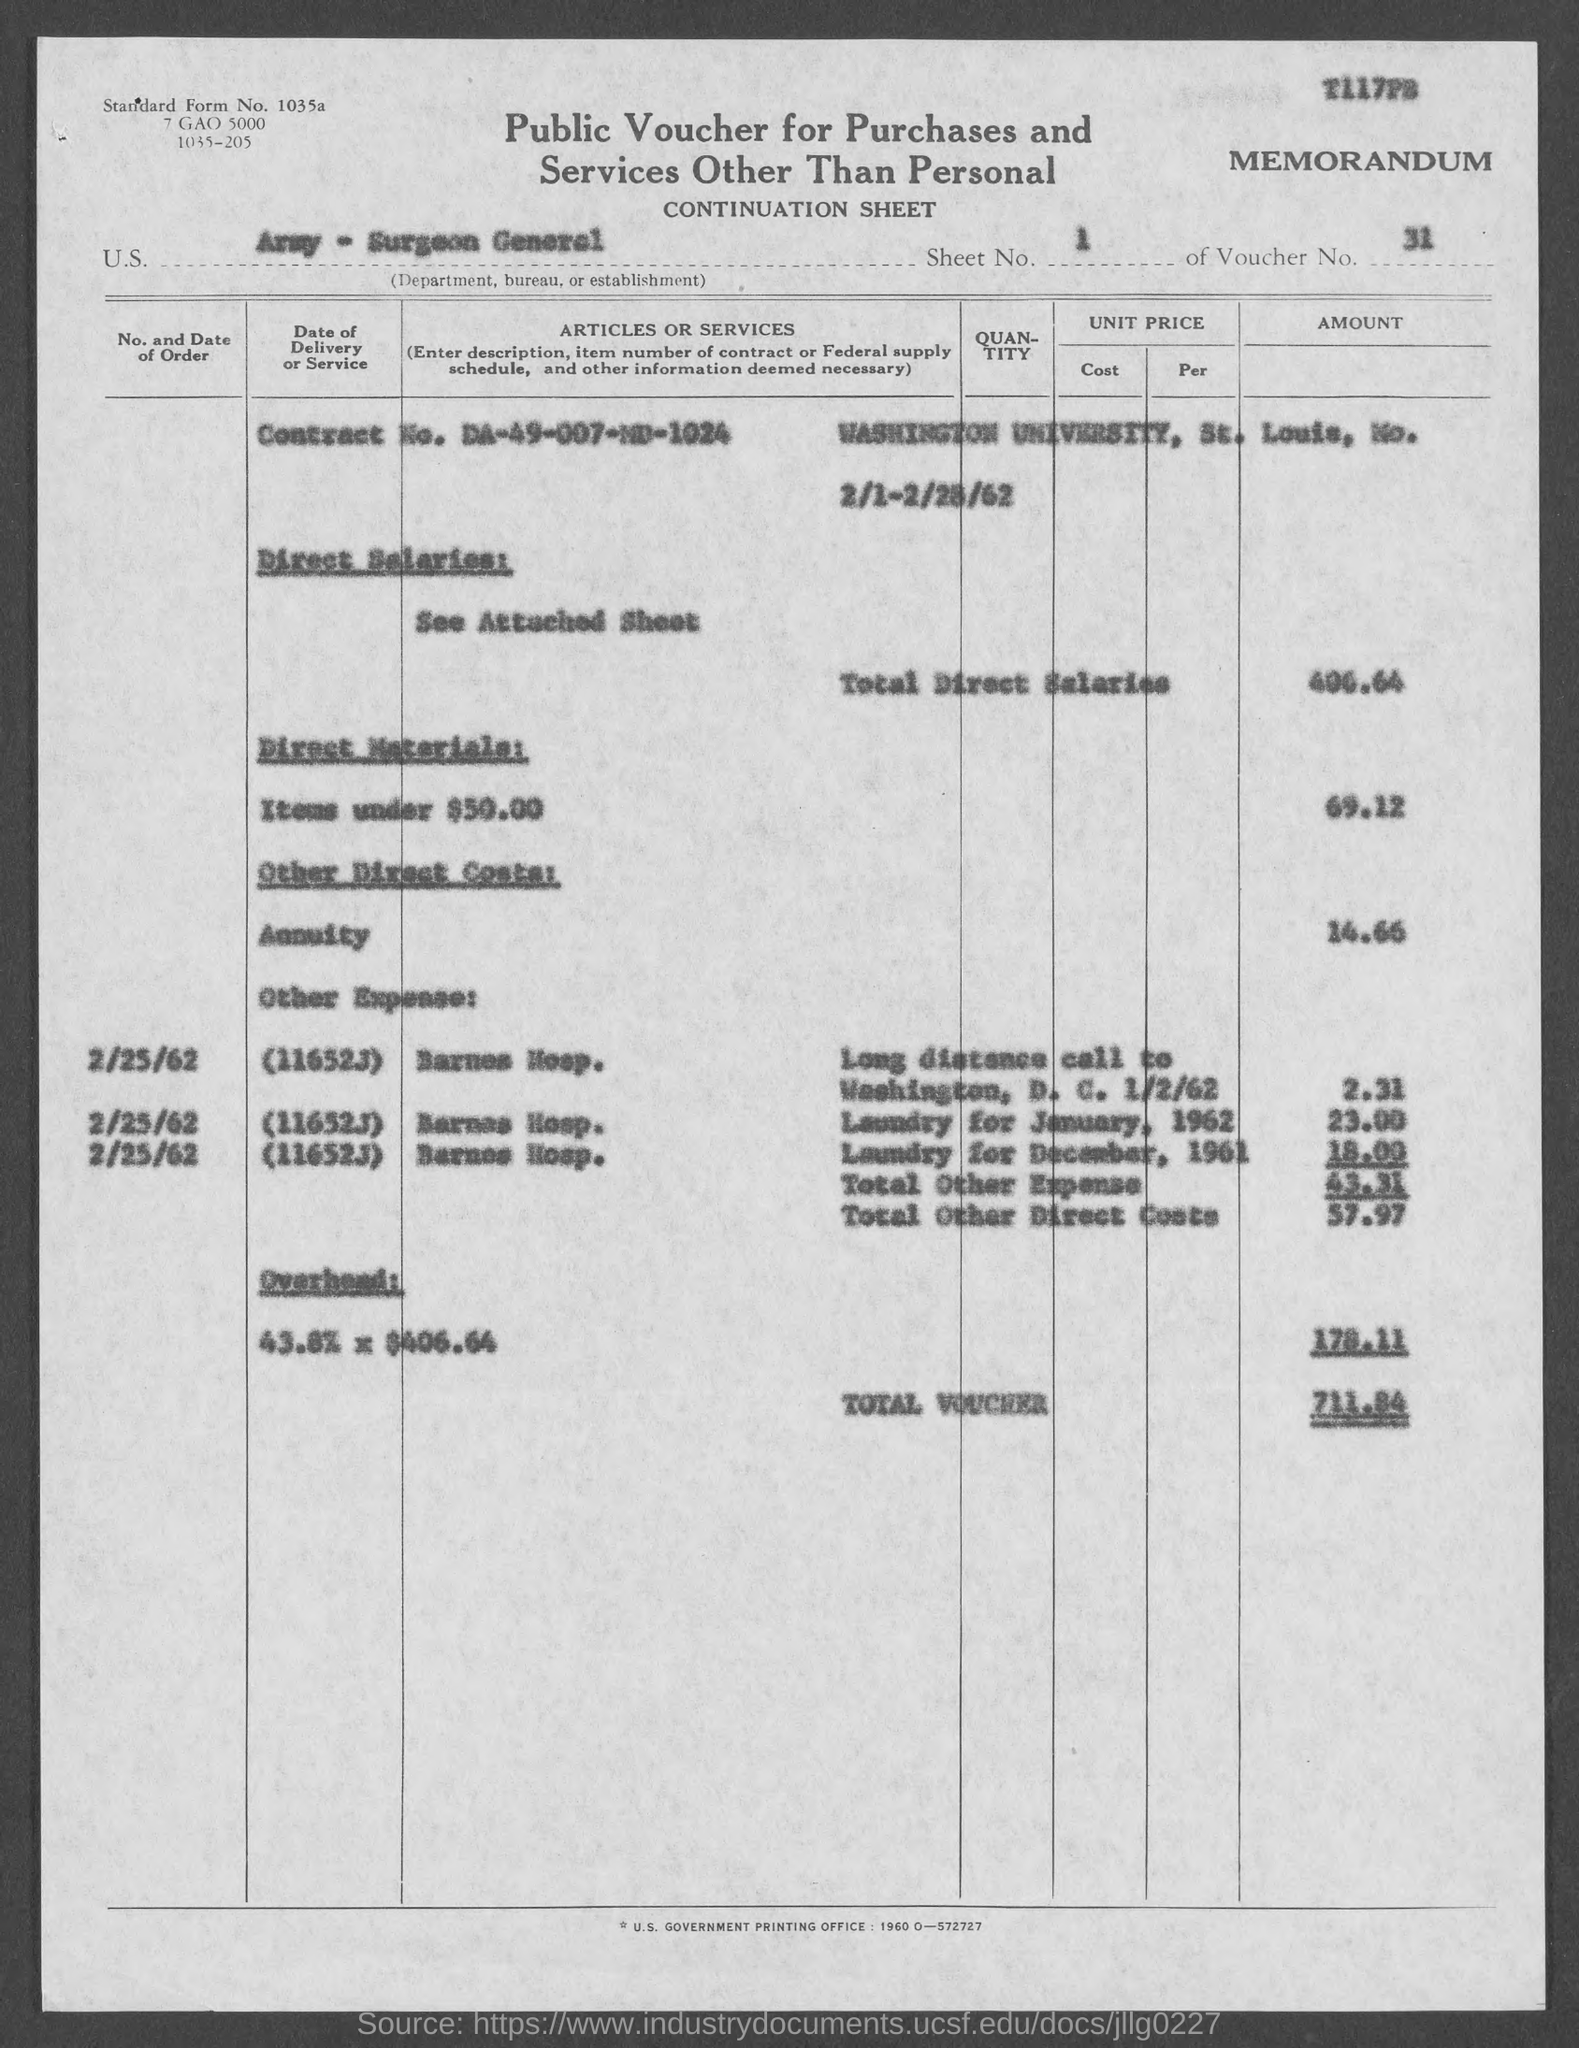Identify some key points in this picture. What is the sheet number?" the man asked, with a tone of inquiry. What is the standard form number? The total voucher is 711.84. The voucher number is 31. This is a public voucher for purchases and services other than personal. 